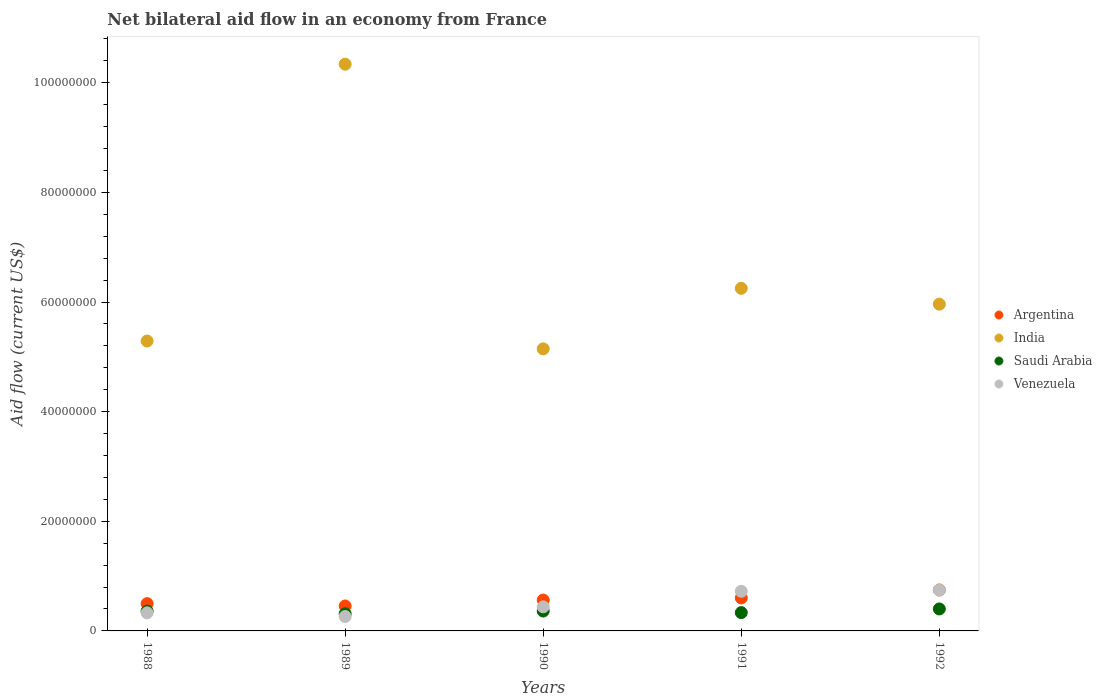Is the number of dotlines equal to the number of legend labels?
Ensure brevity in your answer.  Yes. What is the net bilateral aid flow in Venezuela in 1991?
Keep it short and to the point. 7.23e+06. Across all years, what is the maximum net bilateral aid flow in Venezuela?
Make the answer very short. 7.46e+06. Across all years, what is the minimum net bilateral aid flow in Saudi Arabia?
Ensure brevity in your answer.  3.13e+06. In which year was the net bilateral aid flow in India maximum?
Ensure brevity in your answer.  1989. In which year was the net bilateral aid flow in India minimum?
Provide a short and direct response. 1990. What is the total net bilateral aid flow in India in the graph?
Offer a very short reply. 3.30e+08. What is the difference between the net bilateral aid flow in Saudi Arabia in 1989 and that in 1992?
Your response must be concise. -8.80e+05. What is the difference between the net bilateral aid flow in Venezuela in 1991 and the net bilateral aid flow in Argentina in 1988?
Your answer should be very brief. 2.25e+06. What is the average net bilateral aid flow in India per year?
Offer a terse response. 6.60e+07. In the year 1990, what is the difference between the net bilateral aid flow in India and net bilateral aid flow in Venezuela?
Your answer should be very brief. 4.71e+07. What is the ratio of the net bilateral aid flow in Venezuela in 1988 to that in 1991?
Provide a short and direct response. 0.46. What is the difference between the highest and the second highest net bilateral aid flow in India?
Your answer should be very brief. 4.09e+07. What is the difference between the highest and the lowest net bilateral aid flow in India?
Ensure brevity in your answer.  5.19e+07. Is it the case that in every year, the sum of the net bilateral aid flow in Argentina and net bilateral aid flow in Venezuela  is greater than the sum of net bilateral aid flow in Saudi Arabia and net bilateral aid flow in India?
Ensure brevity in your answer.  No. Is it the case that in every year, the sum of the net bilateral aid flow in Saudi Arabia and net bilateral aid flow in India  is greater than the net bilateral aid flow in Argentina?
Your answer should be compact. Yes. Is the net bilateral aid flow in Argentina strictly greater than the net bilateral aid flow in India over the years?
Offer a terse response. No. Is the net bilateral aid flow in Argentina strictly less than the net bilateral aid flow in India over the years?
Your response must be concise. Yes. Are the values on the major ticks of Y-axis written in scientific E-notation?
Offer a terse response. No. Where does the legend appear in the graph?
Keep it short and to the point. Center right. What is the title of the graph?
Ensure brevity in your answer.  Net bilateral aid flow in an economy from France. Does "Benin" appear as one of the legend labels in the graph?
Give a very brief answer. No. What is the label or title of the X-axis?
Your answer should be compact. Years. What is the label or title of the Y-axis?
Give a very brief answer. Aid flow (current US$). What is the Aid flow (current US$) of Argentina in 1988?
Your answer should be very brief. 4.98e+06. What is the Aid flow (current US$) in India in 1988?
Offer a terse response. 5.29e+07. What is the Aid flow (current US$) of Saudi Arabia in 1988?
Offer a very short reply. 3.62e+06. What is the Aid flow (current US$) in Venezuela in 1988?
Ensure brevity in your answer.  3.30e+06. What is the Aid flow (current US$) of Argentina in 1989?
Your answer should be very brief. 4.55e+06. What is the Aid flow (current US$) in India in 1989?
Ensure brevity in your answer.  1.03e+08. What is the Aid flow (current US$) in Saudi Arabia in 1989?
Keep it short and to the point. 3.13e+06. What is the Aid flow (current US$) in Venezuela in 1989?
Your answer should be compact. 2.63e+06. What is the Aid flow (current US$) in Argentina in 1990?
Make the answer very short. 5.63e+06. What is the Aid flow (current US$) in India in 1990?
Provide a short and direct response. 5.15e+07. What is the Aid flow (current US$) of Saudi Arabia in 1990?
Provide a short and direct response. 3.63e+06. What is the Aid flow (current US$) of Venezuela in 1990?
Offer a very short reply. 4.39e+06. What is the Aid flow (current US$) in Argentina in 1991?
Keep it short and to the point. 6.02e+06. What is the Aid flow (current US$) in India in 1991?
Offer a very short reply. 6.25e+07. What is the Aid flow (current US$) in Saudi Arabia in 1991?
Provide a succinct answer. 3.34e+06. What is the Aid flow (current US$) of Venezuela in 1991?
Provide a short and direct response. 7.23e+06. What is the Aid flow (current US$) in Argentina in 1992?
Your answer should be compact. 7.47e+06. What is the Aid flow (current US$) of India in 1992?
Make the answer very short. 5.96e+07. What is the Aid flow (current US$) in Saudi Arabia in 1992?
Keep it short and to the point. 4.01e+06. What is the Aid flow (current US$) of Venezuela in 1992?
Your answer should be compact. 7.46e+06. Across all years, what is the maximum Aid flow (current US$) of Argentina?
Offer a very short reply. 7.47e+06. Across all years, what is the maximum Aid flow (current US$) in India?
Give a very brief answer. 1.03e+08. Across all years, what is the maximum Aid flow (current US$) in Saudi Arabia?
Your answer should be compact. 4.01e+06. Across all years, what is the maximum Aid flow (current US$) of Venezuela?
Offer a very short reply. 7.46e+06. Across all years, what is the minimum Aid flow (current US$) of Argentina?
Provide a succinct answer. 4.55e+06. Across all years, what is the minimum Aid flow (current US$) in India?
Provide a succinct answer. 5.15e+07. Across all years, what is the minimum Aid flow (current US$) of Saudi Arabia?
Provide a succinct answer. 3.13e+06. Across all years, what is the minimum Aid flow (current US$) in Venezuela?
Your response must be concise. 2.63e+06. What is the total Aid flow (current US$) of Argentina in the graph?
Your answer should be compact. 2.86e+07. What is the total Aid flow (current US$) of India in the graph?
Make the answer very short. 3.30e+08. What is the total Aid flow (current US$) in Saudi Arabia in the graph?
Offer a very short reply. 1.77e+07. What is the total Aid flow (current US$) in Venezuela in the graph?
Your response must be concise. 2.50e+07. What is the difference between the Aid flow (current US$) of Argentina in 1988 and that in 1989?
Offer a very short reply. 4.30e+05. What is the difference between the Aid flow (current US$) in India in 1988 and that in 1989?
Offer a terse response. -5.05e+07. What is the difference between the Aid flow (current US$) of Venezuela in 1988 and that in 1989?
Your response must be concise. 6.70e+05. What is the difference between the Aid flow (current US$) in Argentina in 1988 and that in 1990?
Provide a succinct answer. -6.50e+05. What is the difference between the Aid flow (current US$) in India in 1988 and that in 1990?
Provide a succinct answer. 1.43e+06. What is the difference between the Aid flow (current US$) of Venezuela in 1988 and that in 1990?
Offer a very short reply. -1.09e+06. What is the difference between the Aid flow (current US$) of Argentina in 1988 and that in 1991?
Provide a short and direct response. -1.04e+06. What is the difference between the Aid flow (current US$) of India in 1988 and that in 1991?
Provide a short and direct response. -9.61e+06. What is the difference between the Aid flow (current US$) of Saudi Arabia in 1988 and that in 1991?
Your answer should be compact. 2.80e+05. What is the difference between the Aid flow (current US$) in Venezuela in 1988 and that in 1991?
Provide a succinct answer. -3.93e+06. What is the difference between the Aid flow (current US$) in Argentina in 1988 and that in 1992?
Offer a terse response. -2.49e+06. What is the difference between the Aid flow (current US$) of India in 1988 and that in 1992?
Keep it short and to the point. -6.72e+06. What is the difference between the Aid flow (current US$) of Saudi Arabia in 1988 and that in 1992?
Keep it short and to the point. -3.90e+05. What is the difference between the Aid flow (current US$) of Venezuela in 1988 and that in 1992?
Keep it short and to the point. -4.16e+06. What is the difference between the Aid flow (current US$) in Argentina in 1989 and that in 1990?
Offer a very short reply. -1.08e+06. What is the difference between the Aid flow (current US$) in India in 1989 and that in 1990?
Provide a short and direct response. 5.19e+07. What is the difference between the Aid flow (current US$) in Saudi Arabia in 1989 and that in 1990?
Make the answer very short. -5.00e+05. What is the difference between the Aid flow (current US$) of Venezuela in 1989 and that in 1990?
Your answer should be compact. -1.76e+06. What is the difference between the Aid flow (current US$) in Argentina in 1989 and that in 1991?
Ensure brevity in your answer.  -1.47e+06. What is the difference between the Aid flow (current US$) in India in 1989 and that in 1991?
Give a very brief answer. 4.09e+07. What is the difference between the Aid flow (current US$) of Saudi Arabia in 1989 and that in 1991?
Ensure brevity in your answer.  -2.10e+05. What is the difference between the Aid flow (current US$) in Venezuela in 1989 and that in 1991?
Ensure brevity in your answer.  -4.60e+06. What is the difference between the Aid flow (current US$) in Argentina in 1989 and that in 1992?
Offer a terse response. -2.92e+06. What is the difference between the Aid flow (current US$) of India in 1989 and that in 1992?
Make the answer very short. 4.38e+07. What is the difference between the Aid flow (current US$) in Saudi Arabia in 1989 and that in 1992?
Ensure brevity in your answer.  -8.80e+05. What is the difference between the Aid flow (current US$) in Venezuela in 1989 and that in 1992?
Your answer should be compact. -4.83e+06. What is the difference between the Aid flow (current US$) of Argentina in 1990 and that in 1991?
Keep it short and to the point. -3.90e+05. What is the difference between the Aid flow (current US$) in India in 1990 and that in 1991?
Provide a short and direct response. -1.10e+07. What is the difference between the Aid flow (current US$) of Saudi Arabia in 1990 and that in 1991?
Your answer should be compact. 2.90e+05. What is the difference between the Aid flow (current US$) in Venezuela in 1990 and that in 1991?
Offer a terse response. -2.84e+06. What is the difference between the Aid flow (current US$) of Argentina in 1990 and that in 1992?
Ensure brevity in your answer.  -1.84e+06. What is the difference between the Aid flow (current US$) of India in 1990 and that in 1992?
Provide a succinct answer. -8.15e+06. What is the difference between the Aid flow (current US$) of Saudi Arabia in 1990 and that in 1992?
Your answer should be very brief. -3.80e+05. What is the difference between the Aid flow (current US$) of Venezuela in 1990 and that in 1992?
Provide a succinct answer. -3.07e+06. What is the difference between the Aid flow (current US$) of Argentina in 1991 and that in 1992?
Provide a short and direct response. -1.45e+06. What is the difference between the Aid flow (current US$) in India in 1991 and that in 1992?
Your answer should be compact. 2.89e+06. What is the difference between the Aid flow (current US$) of Saudi Arabia in 1991 and that in 1992?
Give a very brief answer. -6.70e+05. What is the difference between the Aid flow (current US$) of Venezuela in 1991 and that in 1992?
Offer a very short reply. -2.30e+05. What is the difference between the Aid flow (current US$) in Argentina in 1988 and the Aid flow (current US$) in India in 1989?
Offer a very short reply. -9.84e+07. What is the difference between the Aid flow (current US$) of Argentina in 1988 and the Aid flow (current US$) of Saudi Arabia in 1989?
Provide a succinct answer. 1.85e+06. What is the difference between the Aid flow (current US$) in Argentina in 1988 and the Aid flow (current US$) in Venezuela in 1989?
Provide a succinct answer. 2.35e+06. What is the difference between the Aid flow (current US$) of India in 1988 and the Aid flow (current US$) of Saudi Arabia in 1989?
Provide a succinct answer. 4.98e+07. What is the difference between the Aid flow (current US$) in India in 1988 and the Aid flow (current US$) in Venezuela in 1989?
Your answer should be very brief. 5.03e+07. What is the difference between the Aid flow (current US$) of Saudi Arabia in 1988 and the Aid flow (current US$) of Venezuela in 1989?
Keep it short and to the point. 9.90e+05. What is the difference between the Aid flow (current US$) in Argentina in 1988 and the Aid flow (current US$) in India in 1990?
Make the answer very short. -4.65e+07. What is the difference between the Aid flow (current US$) of Argentina in 1988 and the Aid flow (current US$) of Saudi Arabia in 1990?
Keep it short and to the point. 1.35e+06. What is the difference between the Aid flow (current US$) of Argentina in 1988 and the Aid flow (current US$) of Venezuela in 1990?
Your answer should be very brief. 5.90e+05. What is the difference between the Aid flow (current US$) of India in 1988 and the Aid flow (current US$) of Saudi Arabia in 1990?
Ensure brevity in your answer.  4.93e+07. What is the difference between the Aid flow (current US$) of India in 1988 and the Aid flow (current US$) of Venezuela in 1990?
Offer a very short reply. 4.85e+07. What is the difference between the Aid flow (current US$) of Saudi Arabia in 1988 and the Aid flow (current US$) of Venezuela in 1990?
Make the answer very short. -7.70e+05. What is the difference between the Aid flow (current US$) of Argentina in 1988 and the Aid flow (current US$) of India in 1991?
Offer a terse response. -5.75e+07. What is the difference between the Aid flow (current US$) of Argentina in 1988 and the Aid flow (current US$) of Saudi Arabia in 1991?
Provide a succinct answer. 1.64e+06. What is the difference between the Aid flow (current US$) of Argentina in 1988 and the Aid flow (current US$) of Venezuela in 1991?
Ensure brevity in your answer.  -2.25e+06. What is the difference between the Aid flow (current US$) of India in 1988 and the Aid flow (current US$) of Saudi Arabia in 1991?
Give a very brief answer. 4.96e+07. What is the difference between the Aid flow (current US$) of India in 1988 and the Aid flow (current US$) of Venezuela in 1991?
Give a very brief answer. 4.57e+07. What is the difference between the Aid flow (current US$) of Saudi Arabia in 1988 and the Aid flow (current US$) of Venezuela in 1991?
Ensure brevity in your answer.  -3.61e+06. What is the difference between the Aid flow (current US$) in Argentina in 1988 and the Aid flow (current US$) in India in 1992?
Provide a succinct answer. -5.46e+07. What is the difference between the Aid flow (current US$) in Argentina in 1988 and the Aid flow (current US$) in Saudi Arabia in 1992?
Offer a terse response. 9.70e+05. What is the difference between the Aid flow (current US$) in Argentina in 1988 and the Aid flow (current US$) in Venezuela in 1992?
Make the answer very short. -2.48e+06. What is the difference between the Aid flow (current US$) in India in 1988 and the Aid flow (current US$) in Saudi Arabia in 1992?
Offer a terse response. 4.89e+07. What is the difference between the Aid flow (current US$) of India in 1988 and the Aid flow (current US$) of Venezuela in 1992?
Make the answer very short. 4.54e+07. What is the difference between the Aid flow (current US$) of Saudi Arabia in 1988 and the Aid flow (current US$) of Venezuela in 1992?
Your response must be concise. -3.84e+06. What is the difference between the Aid flow (current US$) of Argentina in 1989 and the Aid flow (current US$) of India in 1990?
Your response must be concise. -4.69e+07. What is the difference between the Aid flow (current US$) in Argentina in 1989 and the Aid flow (current US$) in Saudi Arabia in 1990?
Your answer should be compact. 9.20e+05. What is the difference between the Aid flow (current US$) of India in 1989 and the Aid flow (current US$) of Saudi Arabia in 1990?
Your answer should be compact. 9.98e+07. What is the difference between the Aid flow (current US$) of India in 1989 and the Aid flow (current US$) of Venezuela in 1990?
Provide a succinct answer. 9.90e+07. What is the difference between the Aid flow (current US$) in Saudi Arabia in 1989 and the Aid flow (current US$) in Venezuela in 1990?
Offer a terse response. -1.26e+06. What is the difference between the Aid flow (current US$) of Argentina in 1989 and the Aid flow (current US$) of India in 1991?
Make the answer very short. -5.80e+07. What is the difference between the Aid flow (current US$) in Argentina in 1989 and the Aid flow (current US$) in Saudi Arabia in 1991?
Provide a succinct answer. 1.21e+06. What is the difference between the Aid flow (current US$) of Argentina in 1989 and the Aid flow (current US$) of Venezuela in 1991?
Your response must be concise. -2.68e+06. What is the difference between the Aid flow (current US$) in India in 1989 and the Aid flow (current US$) in Saudi Arabia in 1991?
Give a very brief answer. 1.00e+08. What is the difference between the Aid flow (current US$) of India in 1989 and the Aid flow (current US$) of Venezuela in 1991?
Your response must be concise. 9.62e+07. What is the difference between the Aid flow (current US$) of Saudi Arabia in 1989 and the Aid flow (current US$) of Venezuela in 1991?
Your response must be concise. -4.10e+06. What is the difference between the Aid flow (current US$) of Argentina in 1989 and the Aid flow (current US$) of India in 1992?
Keep it short and to the point. -5.51e+07. What is the difference between the Aid flow (current US$) in Argentina in 1989 and the Aid flow (current US$) in Saudi Arabia in 1992?
Provide a short and direct response. 5.40e+05. What is the difference between the Aid flow (current US$) of Argentina in 1989 and the Aid flow (current US$) of Venezuela in 1992?
Your answer should be compact. -2.91e+06. What is the difference between the Aid flow (current US$) in India in 1989 and the Aid flow (current US$) in Saudi Arabia in 1992?
Offer a very short reply. 9.94e+07. What is the difference between the Aid flow (current US$) in India in 1989 and the Aid flow (current US$) in Venezuela in 1992?
Provide a short and direct response. 9.59e+07. What is the difference between the Aid flow (current US$) in Saudi Arabia in 1989 and the Aid flow (current US$) in Venezuela in 1992?
Give a very brief answer. -4.33e+06. What is the difference between the Aid flow (current US$) of Argentina in 1990 and the Aid flow (current US$) of India in 1991?
Provide a short and direct response. -5.69e+07. What is the difference between the Aid flow (current US$) of Argentina in 1990 and the Aid flow (current US$) of Saudi Arabia in 1991?
Offer a very short reply. 2.29e+06. What is the difference between the Aid flow (current US$) of Argentina in 1990 and the Aid flow (current US$) of Venezuela in 1991?
Offer a terse response. -1.60e+06. What is the difference between the Aid flow (current US$) of India in 1990 and the Aid flow (current US$) of Saudi Arabia in 1991?
Keep it short and to the point. 4.81e+07. What is the difference between the Aid flow (current US$) in India in 1990 and the Aid flow (current US$) in Venezuela in 1991?
Offer a terse response. 4.42e+07. What is the difference between the Aid flow (current US$) of Saudi Arabia in 1990 and the Aid flow (current US$) of Venezuela in 1991?
Give a very brief answer. -3.60e+06. What is the difference between the Aid flow (current US$) in Argentina in 1990 and the Aid flow (current US$) in India in 1992?
Your answer should be very brief. -5.40e+07. What is the difference between the Aid flow (current US$) of Argentina in 1990 and the Aid flow (current US$) of Saudi Arabia in 1992?
Provide a succinct answer. 1.62e+06. What is the difference between the Aid flow (current US$) of Argentina in 1990 and the Aid flow (current US$) of Venezuela in 1992?
Your response must be concise. -1.83e+06. What is the difference between the Aid flow (current US$) of India in 1990 and the Aid flow (current US$) of Saudi Arabia in 1992?
Keep it short and to the point. 4.74e+07. What is the difference between the Aid flow (current US$) of India in 1990 and the Aid flow (current US$) of Venezuela in 1992?
Your answer should be very brief. 4.40e+07. What is the difference between the Aid flow (current US$) in Saudi Arabia in 1990 and the Aid flow (current US$) in Venezuela in 1992?
Offer a terse response. -3.83e+06. What is the difference between the Aid flow (current US$) in Argentina in 1991 and the Aid flow (current US$) in India in 1992?
Keep it short and to the point. -5.36e+07. What is the difference between the Aid flow (current US$) in Argentina in 1991 and the Aid flow (current US$) in Saudi Arabia in 1992?
Give a very brief answer. 2.01e+06. What is the difference between the Aid flow (current US$) of Argentina in 1991 and the Aid flow (current US$) of Venezuela in 1992?
Offer a very short reply. -1.44e+06. What is the difference between the Aid flow (current US$) of India in 1991 and the Aid flow (current US$) of Saudi Arabia in 1992?
Your answer should be very brief. 5.85e+07. What is the difference between the Aid flow (current US$) of India in 1991 and the Aid flow (current US$) of Venezuela in 1992?
Offer a very short reply. 5.50e+07. What is the difference between the Aid flow (current US$) in Saudi Arabia in 1991 and the Aid flow (current US$) in Venezuela in 1992?
Ensure brevity in your answer.  -4.12e+06. What is the average Aid flow (current US$) of Argentina per year?
Your answer should be compact. 5.73e+06. What is the average Aid flow (current US$) of India per year?
Your answer should be compact. 6.60e+07. What is the average Aid flow (current US$) in Saudi Arabia per year?
Ensure brevity in your answer.  3.55e+06. What is the average Aid flow (current US$) of Venezuela per year?
Your response must be concise. 5.00e+06. In the year 1988, what is the difference between the Aid flow (current US$) of Argentina and Aid flow (current US$) of India?
Your answer should be very brief. -4.79e+07. In the year 1988, what is the difference between the Aid flow (current US$) of Argentina and Aid flow (current US$) of Saudi Arabia?
Provide a short and direct response. 1.36e+06. In the year 1988, what is the difference between the Aid flow (current US$) in Argentina and Aid flow (current US$) in Venezuela?
Offer a terse response. 1.68e+06. In the year 1988, what is the difference between the Aid flow (current US$) of India and Aid flow (current US$) of Saudi Arabia?
Your answer should be very brief. 4.93e+07. In the year 1988, what is the difference between the Aid flow (current US$) of India and Aid flow (current US$) of Venezuela?
Offer a very short reply. 4.96e+07. In the year 1989, what is the difference between the Aid flow (current US$) in Argentina and Aid flow (current US$) in India?
Make the answer very short. -9.88e+07. In the year 1989, what is the difference between the Aid flow (current US$) of Argentina and Aid flow (current US$) of Saudi Arabia?
Make the answer very short. 1.42e+06. In the year 1989, what is the difference between the Aid flow (current US$) of Argentina and Aid flow (current US$) of Venezuela?
Provide a succinct answer. 1.92e+06. In the year 1989, what is the difference between the Aid flow (current US$) of India and Aid flow (current US$) of Saudi Arabia?
Your response must be concise. 1.00e+08. In the year 1989, what is the difference between the Aid flow (current US$) of India and Aid flow (current US$) of Venezuela?
Keep it short and to the point. 1.01e+08. In the year 1990, what is the difference between the Aid flow (current US$) in Argentina and Aid flow (current US$) in India?
Your answer should be compact. -4.58e+07. In the year 1990, what is the difference between the Aid flow (current US$) of Argentina and Aid flow (current US$) of Venezuela?
Your answer should be compact. 1.24e+06. In the year 1990, what is the difference between the Aid flow (current US$) in India and Aid flow (current US$) in Saudi Arabia?
Your answer should be compact. 4.78e+07. In the year 1990, what is the difference between the Aid flow (current US$) of India and Aid flow (current US$) of Venezuela?
Provide a short and direct response. 4.71e+07. In the year 1990, what is the difference between the Aid flow (current US$) in Saudi Arabia and Aid flow (current US$) in Venezuela?
Ensure brevity in your answer.  -7.60e+05. In the year 1991, what is the difference between the Aid flow (current US$) of Argentina and Aid flow (current US$) of India?
Offer a very short reply. -5.65e+07. In the year 1991, what is the difference between the Aid flow (current US$) of Argentina and Aid flow (current US$) of Saudi Arabia?
Ensure brevity in your answer.  2.68e+06. In the year 1991, what is the difference between the Aid flow (current US$) in Argentina and Aid flow (current US$) in Venezuela?
Make the answer very short. -1.21e+06. In the year 1991, what is the difference between the Aid flow (current US$) of India and Aid flow (current US$) of Saudi Arabia?
Offer a very short reply. 5.92e+07. In the year 1991, what is the difference between the Aid flow (current US$) of India and Aid flow (current US$) of Venezuela?
Provide a short and direct response. 5.53e+07. In the year 1991, what is the difference between the Aid flow (current US$) in Saudi Arabia and Aid flow (current US$) in Venezuela?
Your response must be concise. -3.89e+06. In the year 1992, what is the difference between the Aid flow (current US$) of Argentina and Aid flow (current US$) of India?
Ensure brevity in your answer.  -5.21e+07. In the year 1992, what is the difference between the Aid flow (current US$) of Argentina and Aid flow (current US$) of Saudi Arabia?
Provide a succinct answer. 3.46e+06. In the year 1992, what is the difference between the Aid flow (current US$) in India and Aid flow (current US$) in Saudi Arabia?
Provide a succinct answer. 5.56e+07. In the year 1992, what is the difference between the Aid flow (current US$) in India and Aid flow (current US$) in Venezuela?
Keep it short and to the point. 5.22e+07. In the year 1992, what is the difference between the Aid flow (current US$) of Saudi Arabia and Aid flow (current US$) of Venezuela?
Your answer should be very brief. -3.45e+06. What is the ratio of the Aid flow (current US$) in Argentina in 1988 to that in 1989?
Provide a short and direct response. 1.09. What is the ratio of the Aid flow (current US$) in India in 1988 to that in 1989?
Make the answer very short. 0.51. What is the ratio of the Aid flow (current US$) of Saudi Arabia in 1988 to that in 1989?
Offer a terse response. 1.16. What is the ratio of the Aid flow (current US$) in Venezuela in 1988 to that in 1989?
Offer a very short reply. 1.25. What is the ratio of the Aid flow (current US$) in Argentina in 1988 to that in 1990?
Provide a short and direct response. 0.88. What is the ratio of the Aid flow (current US$) of India in 1988 to that in 1990?
Ensure brevity in your answer.  1.03. What is the ratio of the Aid flow (current US$) of Venezuela in 1988 to that in 1990?
Offer a terse response. 0.75. What is the ratio of the Aid flow (current US$) of Argentina in 1988 to that in 1991?
Keep it short and to the point. 0.83. What is the ratio of the Aid flow (current US$) of India in 1988 to that in 1991?
Make the answer very short. 0.85. What is the ratio of the Aid flow (current US$) of Saudi Arabia in 1988 to that in 1991?
Your answer should be very brief. 1.08. What is the ratio of the Aid flow (current US$) in Venezuela in 1988 to that in 1991?
Provide a short and direct response. 0.46. What is the ratio of the Aid flow (current US$) of India in 1988 to that in 1992?
Give a very brief answer. 0.89. What is the ratio of the Aid flow (current US$) of Saudi Arabia in 1988 to that in 1992?
Your answer should be compact. 0.9. What is the ratio of the Aid flow (current US$) in Venezuela in 1988 to that in 1992?
Make the answer very short. 0.44. What is the ratio of the Aid flow (current US$) in Argentina in 1989 to that in 1990?
Make the answer very short. 0.81. What is the ratio of the Aid flow (current US$) in India in 1989 to that in 1990?
Provide a short and direct response. 2.01. What is the ratio of the Aid flow (current US$) in Saudi Arabia in 1989 to that in 1990?
Offer a very short reply. 0.86. What is the ratio of the Aid flow (current US$) of Venezuela in 1989 to that in 1990?
Your answer should be very brief. 0.6. What is the ratio of the Aid flow (current US$) of Argentina in 1989 to that in 1991?
Keep it short and to the point. 0.76. What is the ratio of the Aid flow (current US$) in India in 1989 to that in 1991?
Give a very brief answer. 1.65. What is the ratio of the Aid flow (current US$) in Saudi Arabia in 1989 to that in 1991?
Keep it short and to the point. 0.94. What is the ratio of the Aid flow (current US$) in Venezuela in 1989 to that in 1991?
Provide a succinct answer. 0.36. What is the ratio of the Aid flow (current US$) of Argentina in 1989 to that in 1992?
Ensure brevity in your answer.  0.61. What is the ratio of the Aid flow (current US$) in India in 1989 to that in 1992?
Your answer should be very brief. 1.73. What is the ratio of the Aid flow (current US$) in Saudi Arabia in 1989 to that in 1992?
Keep it short and to the point. 0.78. What is the ratio of the Aid flow (current US$) in Venezuela in 1989 to that in 1992?
Give a very brief answer. 0.35. What is the ratio of the Aid flow (current US$) in Argentina in 1990 to that in 1991?
Provide a short and direct response. 0.94. What is the ratio of the Aid flow (current US$) in India in 1990 to that in 1991?
Your answer should be very brief. 0.82. What is the ratio of the Aid flow (current US$) of Saudi Arabia in 1990 to that in 1991?
Your answer should be very brief. 1.09. What is the ratio of the Aid flow (current US$) in Venezuela in 1990 to that in 1991?
Your response must be concise. 0.61. What is the ratio of the Aid flow (current US$) in Argentina in 1990 to that in 1992?
Keep it short and to the point. 0.75. What is the ratio of the Aid flow (current US$) of India in 1990 to that in 1992?
Make the answer very short. 0.86. What is the ratio of the Aid flow (current US$) of Saudi Arabia in 1990 to that in 1992?
Give a very brief answer. 0.91. What is the ratio of the Aid flow (current US$) of Venezuela in 1990 to that in 1992?
Make the answer very short. 0.59. What is the ratio of the Aid flow (current US$) in Argentina in 1991 to that in 1992?
Offer a terse response. 0.81. What is the ratio of the Aid flow (current US$) of India in 1991 to that in 1992?
Your response must be concise. 1.05. What is the ratio of the Aid flow (current US$) of Saudi Arabia in 1991 to that in 1992?
Offer a terse response. 0.83. What is the ratio of the Aid flow (current US$) in Venezuela in 1991 to that in 1992?
Give a very brief answer. 0.97. What is the difference between the highest and the second highest Aid flow (current US$) in Argentina?
Offer a very short reply. 1.45e+06. What is the difference between the highest and the second highest Aid flow (current US$) in India?
Provide a succinct answer. 4.09e+07. What is the difference between the highest and the second highest Aid flow (current US$) of Venezuela?
Make the answer very short. 2.30e+05. What is the difference between the highest and the lowest Aid flow (current US$) of Argentina?
Provide a short and direct response. 2.92e+06. What is the difference between the highest and the lowest Aid flow (current US$) in India?
Your answer should be compact. 5.19e+07. What is the difference between the highest and the lowest Aid flow (current US$) of Saudi Arabia?
Provide a succinct answer. 8.80e+05. What is the difference between the highest and the lowest Aid flow (current US$) of Venezuela?
Provide a short and direct response. 4.83e+06. 